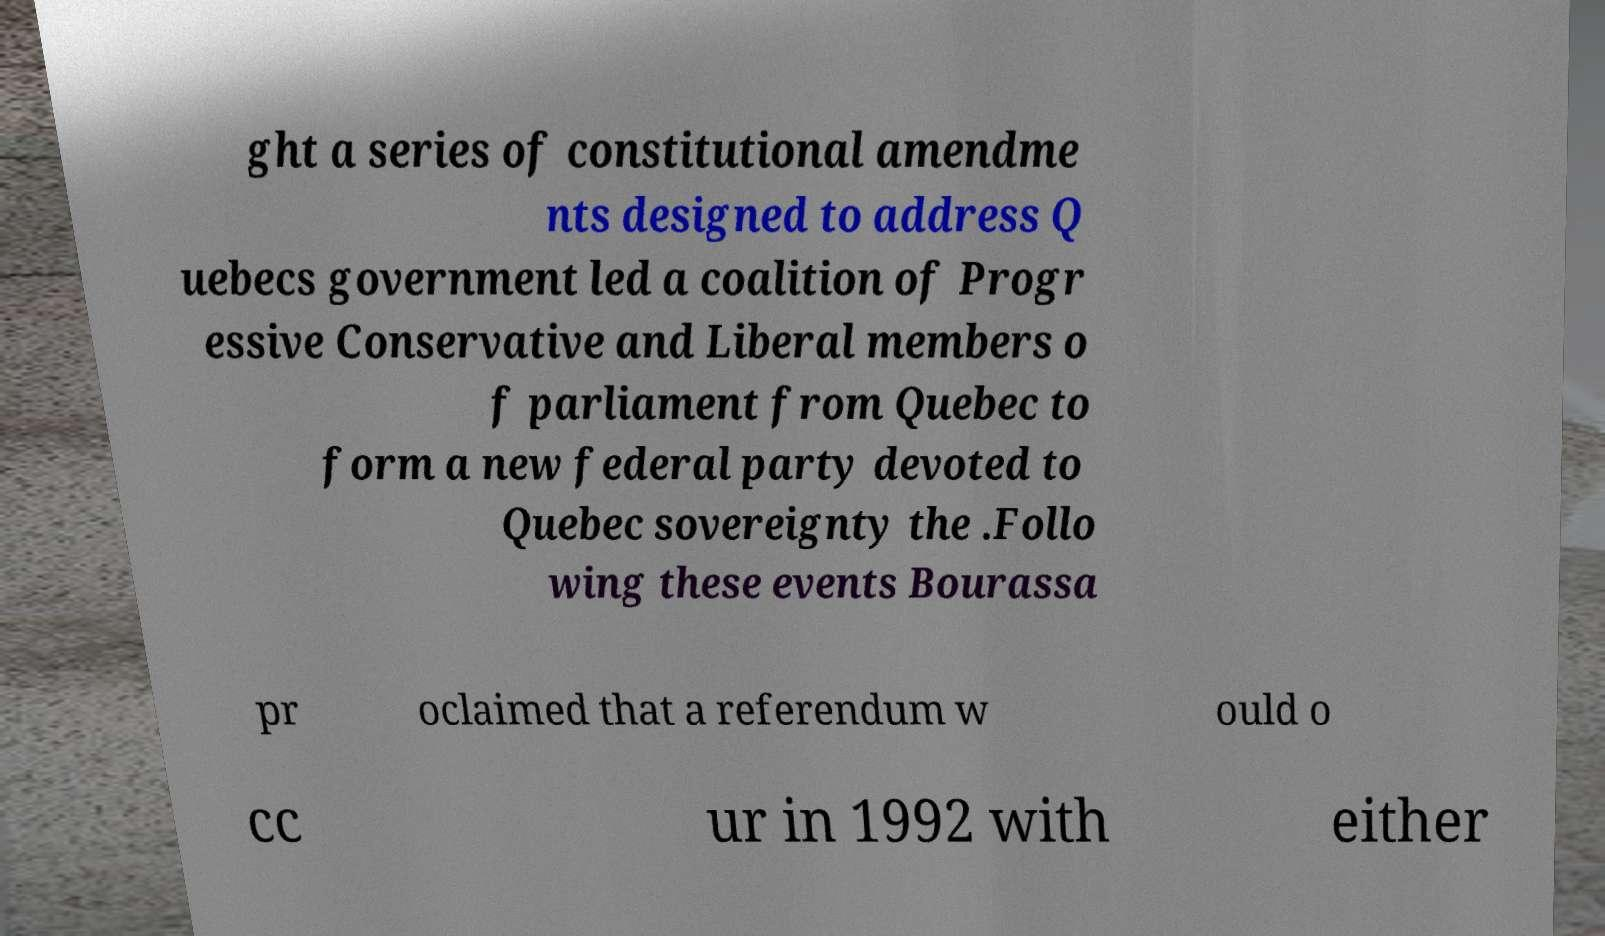I need the written content from this picture converted into text. Can you do that? ght a series of constitutional amendme nts designed to address Q uebecs government led a coalition of Progr essive Conservative and Liberal members o f parliament from Quebec to form a new federal party devoted to Quebec sovereignty the .Follo wing these events Bourassa pr oclaimed that a referendum w ould o cc ur in 1992 with either 